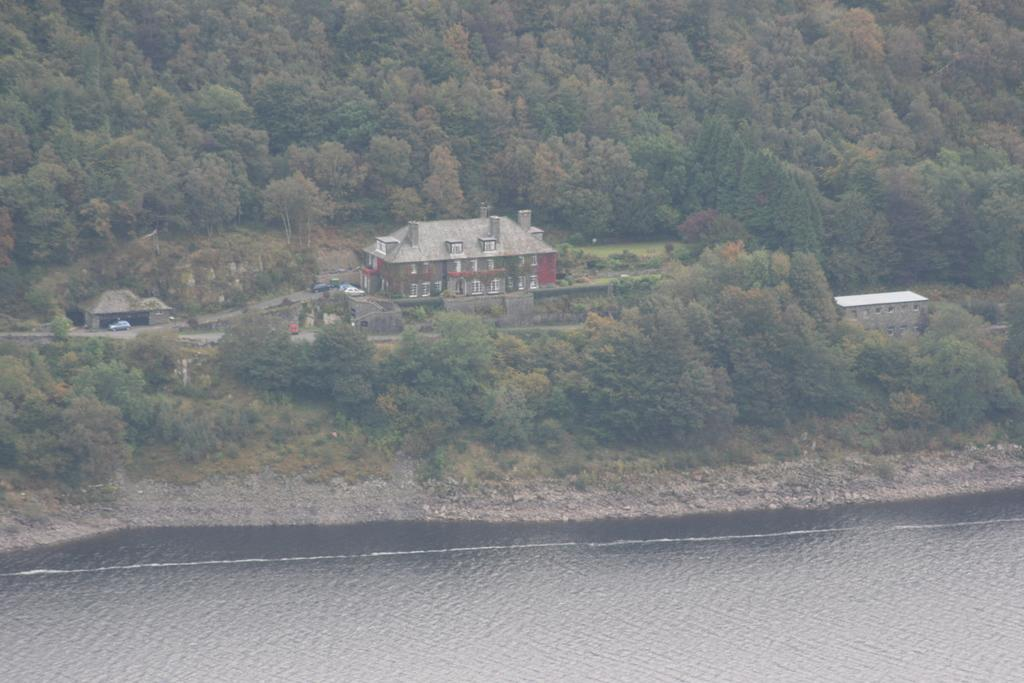What is at the bottom of the image? There is water at the bottom of the image. What can be seen in the middle of the image? There are trees and buildings in the middle of the image. What else is present in the middle of the image? There are vehicles in the middle of the image. What type of vegetable is being used as a trick to invent a new mode of transportation in the image? There is no vegetable, trick, or invention related to transportation present in the image. 